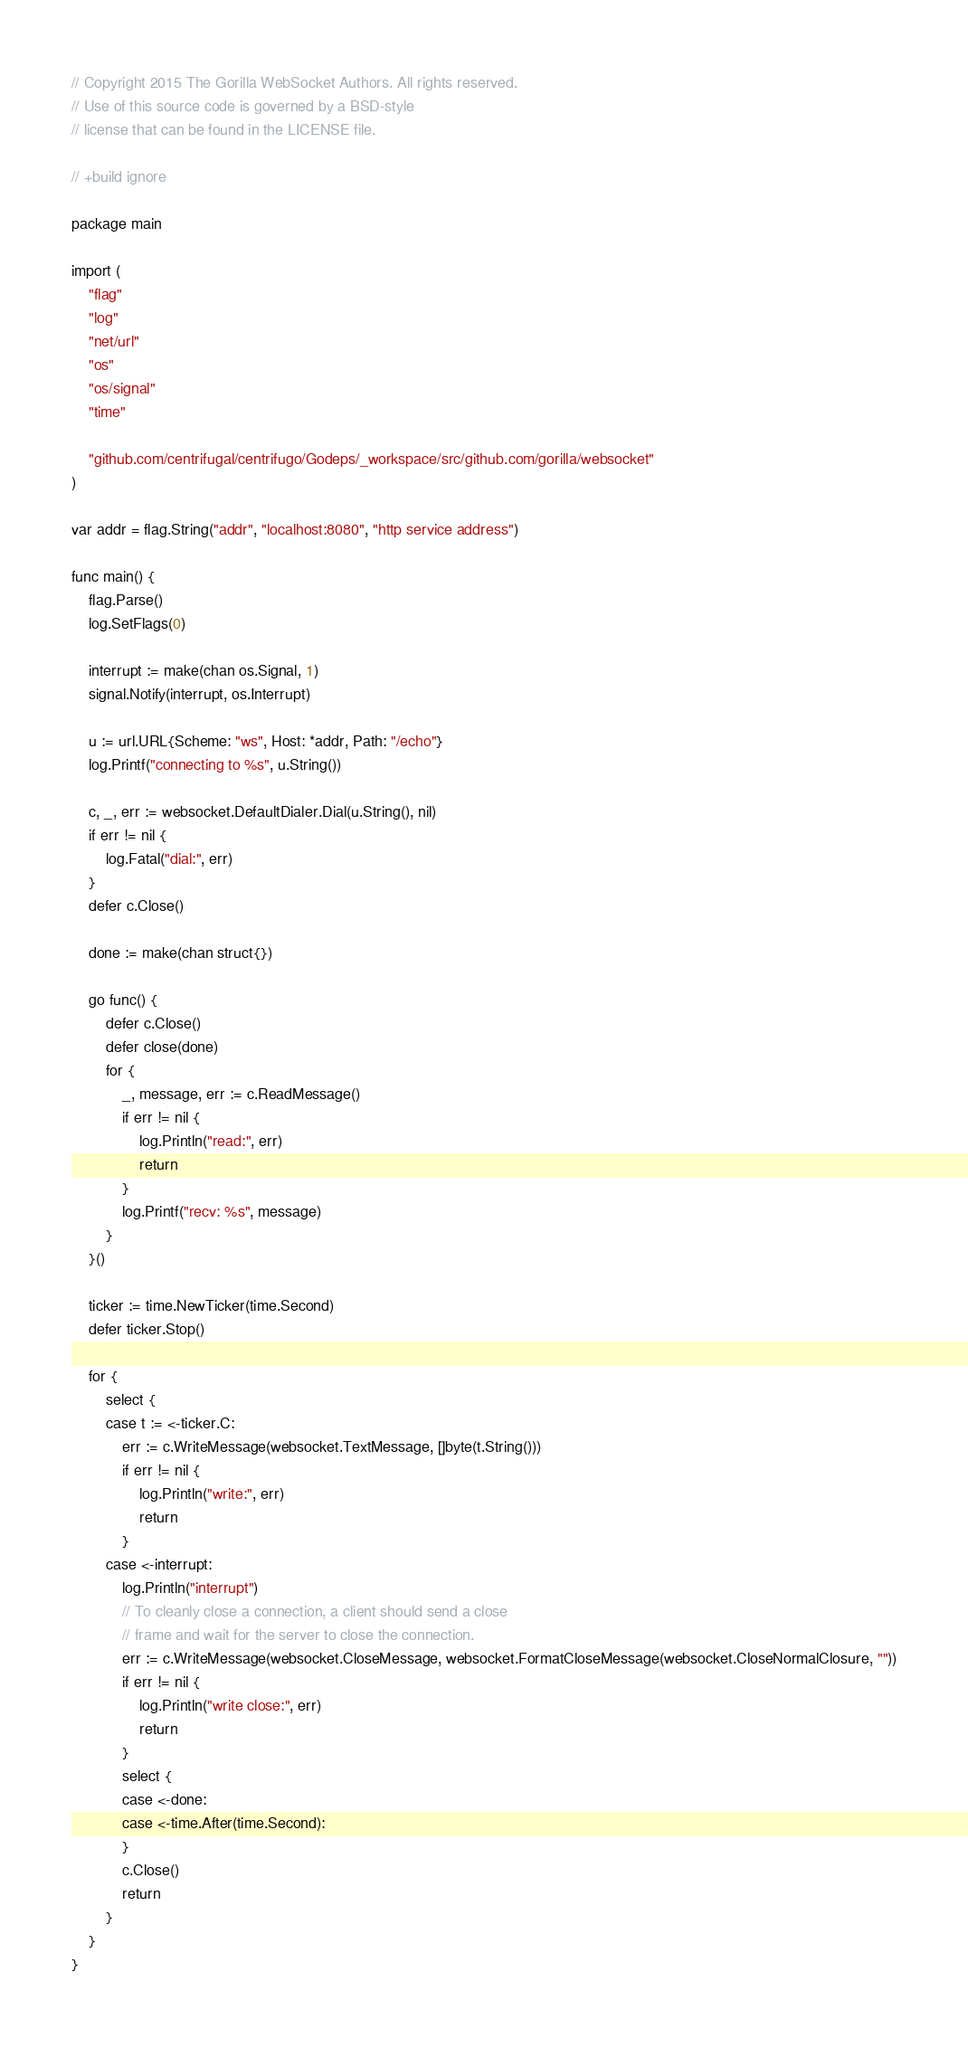Convert code to text. <code><loc_0><loc_0><loc_500><loc_500><_Go_>// Copyright 2015 The Gorilla WebSocket Authors. All rights reserved.
// Use of this source code is governed by a BSD-style
// license that can be found in the LICENSE file.

// +build ignore

package main

import (
	"flag"
	"log"
	"net/url"
	"os"
	"os/signal"
	"time"

	"github.com/centrifugal/centrifugo/Godeps/_workspace/src/github.com/gorilla/websocket"
)

var addr = flag.String("addr", "localhost:8080", "http service address")

func main() {
	flag.Parse()
	log.SetFlags(0)

	interrupt := make(chan os.Signal, 1)
	signal.Notify(interrupt, os.Interrupt)

	u := url.URL{Scheme: "ws", Host: *addr, Path: "/echo"}
	log.Printf("connecting to %s", u.String())

	c, _, err := websocket.DefaultDialer.Dial(u.String(), nil)
	if err != nil {
		log.Fatal("dial:", err)
	}
	defer c.Close()

	done := make(chan struct{})

	go func() {
		defer c.Close()
		defer close(done)
		for {
			_, message, err := c.ReadMessage()
			if err != nil {
				log.Println("read:", err)
				return
			}
			log.Printf("recv: %s", message)
		}
	}()

	ticker := time.NewTicker(time.Second)
	defer ticker.Stop()

	for {
		select {
		case t := <-ticker.C:
			err := c.WriteMessage(websocket.TextMessage, []byte(t.String()))
			if err != nil {
				log.Println("write:", err)
				return
			}
		case <-interrupt:
			log.Println("interrupt")
			// To cleanly close a connection, a client should send a close
			// frame and wait for the server to close the connection.
			err := c.WriteMessage(websocket.CloseMessage, websocket.FormatCloseMessage(websocket.CloseNormalClosure, ""))
			if err != nil {
				log.Println("write close:", err)
				return
			}
			select {
			case <-done:
			case <-time.After(time.Second):
			}
			c.Close()
			return
		}
	}
}
</code> 